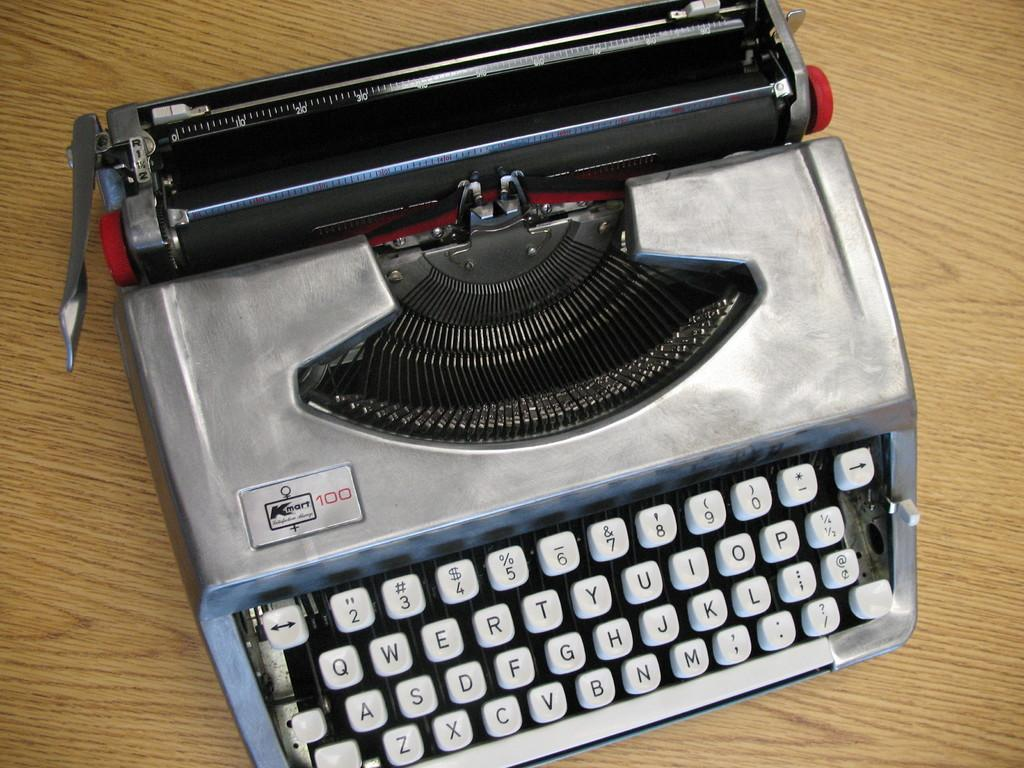<image>
Write a terse but informative summary of the picture. A vintage typewriter sports the name Kmart 100 in the corner. 